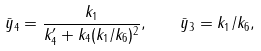Convert formula to latex. <formula><loc_0><loc_0><loc_500><loc_500>\bar { y } _ { 4 } = \frac { k _ { 1 } } { k _ { 4 } ^ { \prime } + k _ { 4 } ( k _ { 1 } / k _ { 6 } ) ^ { 2 } } , \quad \bar { y } _ { 3 } = k _ { 1 } / k _ { 6 } ,</formula> 